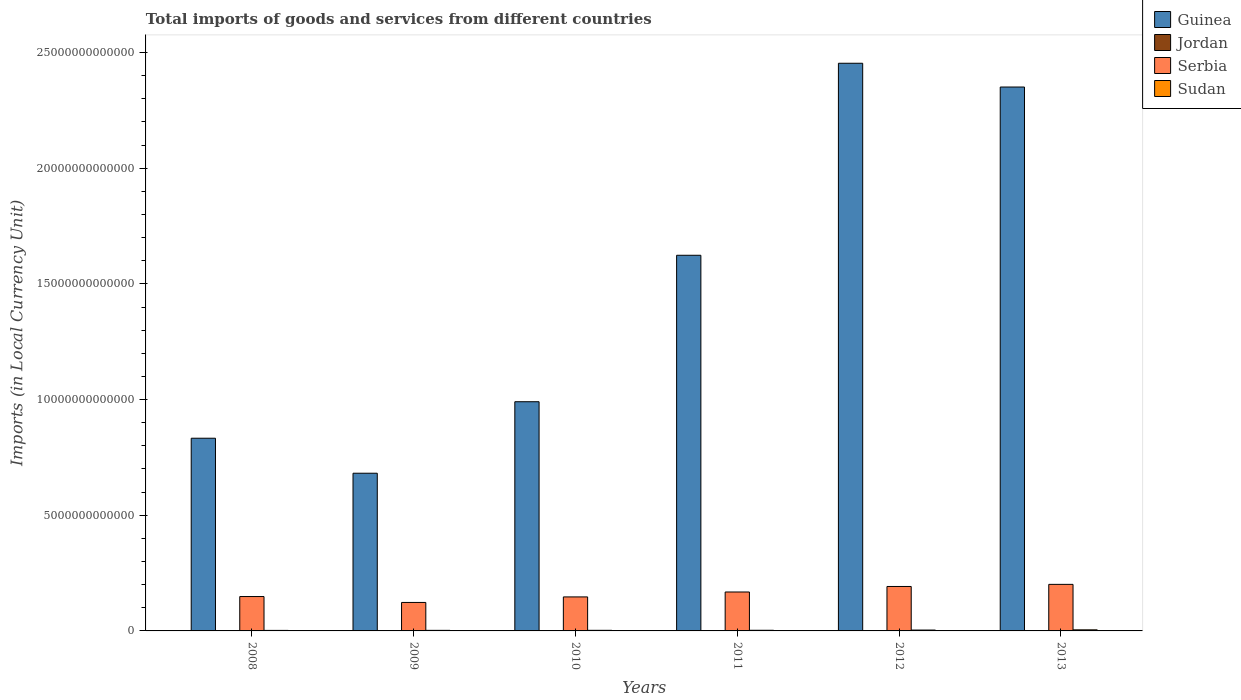How many groups of bars are there?
Your answer should be compact. 6. How many bars are there on the 2nd tick from the left?
Keep it short and to the point. 4. How many bars are there on the 4th tick from the right?
Your answer should be compact. 4. What is the label of the 4th group of bars from the left?
Provide a short and direct response. 2011. In how many cases, is the number of bars for a given year not equal to the number of legend labels?
Offer a terse response. 0. What is the Amount of goods and services imports in Guinea in 2013?
Provide a succinct answer. 2.35e+13. Across all years, what is the maximum Amount of goods and services imports in Serbia?
Provide a short and direct response. 2.01e+12. Across all years, what is the minimum Amount of goods and services imports in Guinea?
Ensure brevity in your answer.  6.82e+12. In which year was the Amount of goods and services imports in Guinea minimum?
Provide a short and direct response. 2009. What is the total Amount of goods and services imports in Guinea in the graph?
Ensure brevity in your answer.  8.93e+13. What is the difference between the Amount of goods and services imports in Serbia in 2010 and that in 2012?
Offer a terse response. -4.51e+11. What is the difference between the Amount of goods and services imports in Jordan in 2008 and the Amount of goods and services imports in Sudan in 2009?
Your answer should be compact. -1.08e+1. What is the average Amount of goods and services imports in Sudan per year?
Make the answer very short. 3.09e+1. In the year 2013, what is the difference between the Amount of goods and services imports in Guinea and Amount of goods and services imports in Serbia?
Provide a succinct answer. 2.15e+13. In how many years, is the Amount of goods and services imports in Guinea greater than 7000000000000 LCU?
Make the answer very short. 5. What is the ratio of the Amount of goods and services imports in Serbia in 2012 to that in 2013?
Make the answer very short. 0.95. Is the Amount of goods and services imports in Guinea in 2008 less than that in 2012?
Provide a succinct answer. Yes. What is the difference between the highest and the second highest Amount of goods and services imports in Sudan?
Your response must be concise. 9.45e+09. What is the difference between the highest and the lowest Amount of goods and services imports in Sudan?
Provide a succinct answer. 2.49e+1. Is the sum of the Amount of goods and services imports in Sudan in 2011 and 2012 greater than the maximum Amount of goods and services imports in Jordan across all years?
Give a very brief answer. Yes. What does the 3rd bar from the left in 2012 represents?
Offer a terse response. Serbia. What does the 4th bar from the right in 2008 represents?
Ensure brevity in your answer.  Guinea. Are all the bars in the graph horizontal?
Give a very brief answer. No. What is the difference between two consecutive major ticks on the Y-axis?
Your answer should be very brief. 5.00e+12. Does the graph contain grids?
Offer a very short reply. No. How are the legend labels stacked?
Make the answer very short. Vertical. What is the title of the graph?
Make the answer very short. Total imports of goods and services from different countries. Does "Channel Islands" appear as one of the legend labels in the graph?
Your answer should be compact. No. What is the label or title of the Y-axis?
Provide a short and direct response. Imports (in Local Currency Unit). What is the Imports (in Local Currency Unit) of Guinea in 2008?
Offer a very short reply. 8.33e+12. What is the Imports (in Local Currency Unit) of Jordan in 2008?
Your answer should be very brief. 1.36e+1. What is the Imports (in Local Currency Unit) in Serbia in 2008?
Ensure brevity in your answer.  1.49e+12. What is the Imports (in Local Currency Unit) in Sudan in 2008?
Offer a very short reply. 2.23e+1. What is the Imports (in Local Currency Unit) of Guinea in 2009?
Keep it short and to the point. 6.82e+12. What is the Imports (in Local Currency Unit) in Jordan in 2009?
Give a very brief answer. 1.17e+1. What is the Imports (in Local Currency Unit) of Serbia in 2009?
Offer a terse response. 1.23e+12. What is the Imports (in Local Currency Unit) of Sudan in 2009?
Provide a short and direct response. 2.45e+1. What is the Imports (in Local Currency Unit) in Guinea in 2010?
Your answer should be very brief. 9.91e+12. What is the Imports (in Local Currency Unit) of Jordan in 2010?
Offer a terse response. 1.30e+1. What is the Imports (in Local Currency Unit) of Serbia in 2010?
Your answer should be very brief. 1.47e+12. What is the Imports (in Local Currency Unit) of Sudan in 2010?
Your response must be concise. 2.61e+1. What is the Imports (in Local Currency Unit) of Guinea in 2011?
Ensure brevity in your answer.  1.62e+13. What is the Imports (in Local Currency Unit) in Jordan in 2011?
Provide a short and direct response. 1.51e+1. What is the Imports (in Local Currency Unit) in Serbia in 2011?
Offer a very short reply. 1.68e+12. What is the Imports (in Local Currency Unit) in Sudan in 2011?
Your answer should be compact. 2.79e+1. What is the Imports (in Local Currency Unit) of Guinea in 2012?
Make the answer very short. 2.45e+13. What is the Imports (in Local Currency Unit) in Jordan in 2012?
Provide a succinct answer. 1.63e+1. What is the Imports (in Local Currency Unit) in Serbia in 2012?
Make the answer very short. 1.92e+12. What is the Imports (in Local Currency Unit) in Sudan in 2012?
Provide a short and direct response. 3.77e+1. What is the Imports (in Local Currency Unit) of Guinea in 2013?
Provide a succinct answer. 2.35e+13. What is the Imports (in Local Currency Unit) of Jordan in 2013?
Offer a very short reply. 1.72e+1. What is the Imports (in Local Currency Unit) in Serbia in 2013?
Your answer should be very brief. 2.01e+12. What is the Imports (in Local Currency Unit) of Sudan in 2013?
Your response must be concise. 4.72e+1. Across all years, what is the maximum Imports (in Local Currency Unit) of Guinea?
Your answer should be compact. 2.45e+13. Across all years, what is the maximum Imports (in Local Currency Unit) of Jordan?
Offer a terse response. 1.72e+1. Across all years, what is the maximum Imports (in Local Currency Unit) in Serbia?
Make the answer very short. 2.01e+12. Across all years, what is the maximum Imports (in Local Currency Unit) in Sudan?
Offer a very short reply. 4.72e+1. Across all years, what is the minimum Imports (in Local Currency Unit) of Guinea?
Keep it short and to the point. 6.82e+12. Across all years, what is the minimum Imports (in Local Currency Unit) of Jordan?
Provide a short and direct response. 1.17e+1. Across all years, what is the minimum Imports (in Local Currency Unit) in Serbia?
Your answer should be very brief. 1.23e+12. Across all years, what is the minimum Imports (in Local Currency Unit) of Sudan?
Offer a very short reply. 2.23e+1. What is the total Imports (in Local Currency Unit) in Guinea in the graph?
Make the answer very short. 8.93e+13. What is the total Imports (in Local Currency Unit) of Jordan in the graph?
Give a very brief answer. 8.69e+1. What is the total Imports (in Local Currency Unit) of Serbia in the graph?
Your response must be concise. 9.80e+12. What is the total Imports (in Local Currency Unit) of Sudan in the graph?
Your answer should be very brief. 1.86e+11. What is the difference between the Imports (in Local Currency Unit) in Guinea in 2008 and that in 2009?
Offer a very short reply. 1.51e+12. What is the difference between the Imports (in Local Currency Unit) of Jordan in 2008 and that in 2009?
Your response must be concise. 1.96e+09. What is the difference between the Imports (in Local Currency Unit) in Serbia in 2008 and that in 2009?
Your response must be concise. 2.55e+11. What is the difference between the Imports (in Local Currency Unit) in Sudan in 2008 and that in 2009?
Keep it short and to the point. -2.14e+09. What is the difference between the Imports (in Local Currency Unit) of Guinea in 2008 and that in 2010?
Ensure brevity in your answer.  -1.58e+12. What is the difference between the Imports (in Local Currency Unit) in Jordan in 2008 and that in 2010?
Offer a terse response. 6.95e+08. What is the difference between the Imports (in Local Currency Unit) of Serbia in 2008 and that in 2010?
Ensure brevity in your answer.  1.62e+1. What is the difference between the Imports (in Local Currency Unit) in Sudan in 2008 and that in 2010?
Make the answer very short. -3.75e+09. What is the difference between the Imports (in Local Currency Unit) of Guinea in 2008 and that in 2011?
Your response must be concise. -7.91e+12. What is the difference between the Imports (in Local Currency Unit) of Jordan in 2008 and that in 2011?
Make the answer very short. -1.48e+09. What is the difference between the Imports (in Local Currency Unit) in Serbia in 2008 and that in 2011?
Provide a succinct answer. -1.96e+11. What is the difference between the Imports (in Local Currency Unit) in Sudan in 2008 and that in 2011?
Ensure brevity in your answer.  -5.58e+09. What is the difference between the Imports (in Local Currency Unit) in Guinea in 2008 and that in 2012?
Make the answer very short. -1.62e+13. What is the difference between the Imports (in Local Currency Unit) of Jordan in 2008 and that in 2012?
Your answer should be very brief. -2.67e+09. What is the difference between the Imports (in Local Currency Unit) in Serbia in 2008 and that in 2012?
Ensure brevity in your answer.  -4.35e+11. What is the difference between the Imports (in Local Currency Unit) in Sudan in 2008 and that in 2012?
Your answer should be compact. -1.54e+1. What is the difference between the Imports (in Local Currency Unit) of Guinea in 2008 and that in 2013?
Keep it short and to the point. -1.52e+13. What is the difference between the Imports (in Local Currency Unit) in Jordan in 2008 and that in 2013?
Keep it short and to the point. -3.52e+09. What is the difference between the Imports (in Local Currency Unit) in Serbia in 2008 and that in 2013?
Ensure brevity in your answer.  -5.26e+11. What is the difference between the Imports (in Local Currency Unit) of Sudan in 2008 and that in 2013?
Provide a short and direct response. -2.49e+1. What is the difference between the Imports (in Local Currency Unit) in Guinea in 2009 and that in 2010?
Give a very brief answer. -3.09e+12. What is the difference between the Imports (in Local Currency Unit) in Jordan in 2009 and that in 2010?
Your answer should be compact. -1.27e+09. What is the difference between the Imports (in Local Currency Unit) in Serbia in 2009 and that in 2010?
Provide a short and direct response. -2.39e+11. What is the difference between the Imports (in Local Currency Unit) of Sudan in 2009 and that in 2010?
Your answer should be very brief. -1.62e+09. What is the difference between the Imports (in Local Currency Unit) in Guinea in 2009 and that in 2011?
Keep it short and to the point. -9.42e+12. What is the difference between the Imports (in Local Currency Unit) in Jordan in 2009 and that in 2011?
Your response must be concise. -3.44e+09. What is the difference between the Imports (in Local Currency Unit) of Serbia in 2009 and that in 2011?
Provide a short and direct response. -4.51e+11. What is the difference between the Imports (in Local Currency Unit) of Sudan in 2009 and that in 2011?
Give a very brief answer. -3.44e+09. What is the difference between the Imports (in Local Currency Unit) of Guinea in 2009 and that in 2012?
Keep it short and to the point. -1.77e+13. What is the difference between the Imports (in Local Currency Unit) of Jordan in 2009 and that in 2012?
Provide a short and direct response. -4.63e+09. What is the difference between the Imports (in Local Currency Unit) in Serbia in 2009 and that in 2012?
Provide a succinct answer. -6.90e+11. What is the difference between the Imports (in Local Currency Unit) in Sudan in 2009 and that in 2012?
Ensure brevity in your answer.  -1.33e+1. What is the difference between the Imports (in Local Currency Unit) in Guinea in 2009 and that in 2013?
Your response must be concise. -1.67e+13. What is the difference between the Imports (in Local Currency Unit) in Jordan in 2009 and that in 2013?
Your response must be concise. -5.48e+09. What is the difference between the Imports (in Local Currency Unit) in Serbia in 2009 and that in 2013?
Provide a short and direct response. -7.81e+11. What is the difference between the Imports (in Local Currency Unit) of Sudan in 2009 and that in 2013?
Give a very brief answer. -2.27e+1. What is the difference between the Imports (in Local Currency Unit) of Guinea in 2010 and that in 2011?
Your answer should be compact. -6.33e+12. What is the difference between the Imports (in Local Currency Unit) of Jordan in 2010 and that in 2011?
Give a very brief answer. -2.17e+09. What is the difference between the Imports (in Local Currency Unit) of Serbia in 2010 and that in 2011?
Provide a succinct answer. -2.13e+11. What is the difference between the Imports (in Local Currency Unit) of Sudan in 2010 and that in 2011?
Offer a very short reply. -1.83e+09. What is the difference between the Imports (in Local Currency Unit) in Guinea in 2010 and that in 2012?
Offer a very short reply. -1.46e+13. What is the difference between the Imports (in Local Currency Unit) in Jordan in 2010 and that in 2012?
Provide a succinct answer. -3.36e+09. What is the difference between the Imports (in Local Currency Unit) of Serbia in 2010 and that in 2012?
Give a very brief answer. -4.51e+11. What is the difference between the Imports (in Local Currency Unit) in Sudan in 2010 and that in 2012?
Your response must be concise. -1.17e+1. What is the difference between the Imports (in Local Currency Unit) in Guinea in 2010 and that in 2013?
Make the answer very short. -1.36e+13. What is the difference between the Imports (in Local Currency Unit) of Jordan in 2010 and that in 2013?
Offer a very short reply. -4.21e+09. What is the difference between the Imports (in Local Currency Unit) of Serbia in 2010 and that in 2013?
Your answer should be very brief. -5.42e+11. What is the difference between the Imports (in Local Currency Unit) of Sudan in 2010 and that in 2013?
Offer a terse response. -2.11e+1. What is the difference between the Imports (in Local Currency Unit) in Guinea in 2011 and that in 2012?
Ensure brevity in your answer.  -8.30e+12. What is the difference between the Imports (in Local Currency Unit) in Jordan in 2011 and that in 2012?
Your response must be concise. -1.19e+09. What is the difference between the Imports (in Local Currency Unit) in Serbia in 2011 and that in 2012?
Ensure brevity in your answer.  -2.39e+11. What is the difference between the Imports (in Local Currency Unit) of Sudan in 2011 and that in 2012?
Make the answer very short. -9.83e+09. What is the difference between the Imports (in Local Currency Unit) in Guinea in 2011 and that in 2013?
Offer a terse response. -7.27e+12. What is the difference between the Imports (in Local Currency Unit) in Jordan in 2011 and that in 2013?
Offer a very short reply. -2.04e+09. What is the difference between the Imports (in Local Currency Unit) in Serbia in 2011 and that in 2013?
Provide a short and direct response. -3.30e+11. What is the difference between the Imports (in Local Currency Unit) of Sudan in 2011 and that in 2013?
Ensure brevity in your answer.  -1.93e+1. What is the difference between the Imports (in Local Currency Unit) of Guinea in 2012 and that in 2013?
Offer a terse response. 1.03e+12. What is the difference between the Imports (in Local Currency Unit) in Jordan in 2012 and that in 2013?
Make the answer very short. -8.50e+08. What is the difference between the Imports (in Local Currency Unit) of Serbia in 2012 and that in 2013?
Make the answer very short. -9.12e+1. What is the difference between the Imports (in Local Currency Unit) in Sudan in 2012 and that in 2013?
Your answer should be very brief. -9.45e+09. What is the difference between the Imports (in Local Currency Unit) in Guinea in 2008 and the Imports (in Local Currency Unit) in Jordan in 2009?
Your answer should be very brief. 8.32e+12. What is the difference between the Imports (in Local Currency Unit) in Guinea in 2008 and the Imports (in Local Currency Unit) in Serbia in 2009?
Keep it short and to the point. 7.10e+12. What is the difference between the Imports (in Local Currency Unit) of Guinea in 2008 and the Imports (in Local Currency Unit) of Sudan in 2009?
Offer a terse response. 8.30e+12. What is the difference between the Imports (in Local Currency Unit) in Jordan in 2008 and the Imports (in Local Currency Unit) in Serbia in 2009?
Your response must be concise. -1.22e+12. What is the difference between the Imports (in Local Currency Unit) of Jordan in 2008 and the Imports (in Local Currency Unit) of Sudan in 2009?
Make the answer very short. -1.08e+1. What is the difference between the Imports (in Local Currency Unit) of Serbia in 2008 and the Imports (in Local Currency Unit) of Sudan in 2009?
Offer a terse response. 1.46e+12. What is the difference between the Imports (in Local Currency Unit) of Guinea in 2008 and the Imports (in Local Currency Unit) of Jordan in 2010?
Your answer should be very brief. 8.32e+12. What is the difference between the Imports (in Local Currency Unit) in Guinea in 2008 and the Imports (in Local Currency Unit) in Serbia in 2010?
Your response must be concise. 6.86e+12. What is the difference between the Imports (in Local Currency Unit) in Guinea in 2008 and the Imports (in Local Currency Unit) in Sudan in 2010?
Your answer should be compact. 8.30e+12. What is the difference between the Imports (in Local Currency Unit) in Jordan in 2008 and the Imports (in Local Currency Unit) in Serbia in 2010?
Offer a terse response. -1.46e+12. What is the difference between the Imports (in Local Currency Unit) of Jordan in 2008 and the Imports (in Local Currency Unit) of Sudan in 2010?
Offer a very short reply. -1.24e+1. What is the difference between the Imports (in Local Currency Unit) of Serbia in 2008 and the Imports (in Local Currency Unit) of Sudan in 2010?
Keep it short and to the point. 1.46e+12. What is the difference between the Imports (in Local Currency Unit) of Guinea in 2008 and the Imports (in Local Currency Unit) of Jordan in 2011?
Offer a very short reply. 8.31e+12. What is the difference between the Imports (in Local Currency Unit) in Guinea in 2008 and the Imports (in Local Currency Unit) in Serbia in 2011?
Your response must be concise. 6.65e+12. What is the difference between the Imports (in Local Currency Unit) in Guinea in 2008 and the Imports (in Local Currency Unit) in Sudan in 2011?
Give a very brief answer. 8.30e+12. What is the difference between the Imports (in Local Currency Unit) in Jordan in 2008 and the Imports (in Local Currency Unit) in Serbia in 2011?
Ensure brevity in your answer.  -1.67e+12. What is the difference between the Imports (in Local Currency Unit) of Jordan in 2008 and the Imports (in Local Currency Unit) of Sudan in 2011?
Your answer should be compact. -1.43e+1. What is the difference between the Imports (in Local Currency Unit) in Serbia in 2008 and the Imports (in Local Currency Unit) in Sudan in 2011?
Ensure brevity in your answer.  1.46e+12. What is the difference between the Imports (in Local Currency Unit) in Guinea in 2008 and the Imports (in Local Currency Unit) in Jordan in 2012?
Your answer should be compact. 8.31e+12. What is the difference between the Imports (in Local Currency Unit) of Guinea in 2008 and the Imports (in Local Currency Unit) of Serbia in 2012?
Ensure brevity in your answer.  6.41e+12. What is the difference between the Imports (in Local Currency Unit) of Guinea in 2008 and the Imports (in Local Currency Unit) of Sudan in 2012?
Make the answer very short. 8.29e+12. What is the difference between the Imports (in Local Currency Unit) in Jordan in 2008 and the Imports (in Local Currency Unit) in Serbia in 2012?
Your answer should be compact. -1.91e+12. What is the difference between the Imports (in Local Currency Unit) in Jordan in 2008 and the Imports (in Local Currency Unit) in Sudan in 2012?
Provide a succinct answer. -2.41e+1. What is the difference between the Imports (in Local Currency Unit) in Serbia in 2008 and the Imports (in Local Currency Unit) in Sudan in 2012?
Your answer should be compact. 1.45e+12. What is the difference between the Imports (in Local Currency Unit) of Guinea in 2008 and the Imports (in Local Currency Unit) of Jordan in 2013?
Offer a terse response. 8.31e+12. What is the difference between the Imports (in Local Currency Unit) of Guinea in 2008 and the Imports (in Local Currency Unit) of Serbia in 2013?
Provide a succinct answer. 6.32e+12. What is the difference between the Imports (in Local Currency Unit) of Guinea in 2008 and the Imports (in Local Currency Unit) of Sudan in 2013?
Provide a short and direct response. 8.28e+12. What is the difference between the Imports (in Local Currency Unit) of Jordan in 2008 and the Imports (in Local Currency Unit) of Serbia in 2013?
Make the answer very short. -2.00e+12. What is the difference between the Imports (in Local Currency Unit) of Jordan in 2008 and the Imports (in Local Currency Unit) of Sudan in 2013?
Provide a succinct answer. -3.35e+1. What is the difference between the Imports (in Local Currency Unit) in Serbia in 2008 and the Imports (in Local Currency Unit) in Sudan in 2013?
Make the answer very short. 1.44e+12. What is the difference between the Imports (in Local Currency Unit) in Guinea in 2009 and the Imports (in Local Currency Unit) in Jordan in 2010?
Make the answer very short. 6.80e+12. What is the difference between the Imports (in Local Currency Unit) of Guinea in 2009 and the Imports (in Local Currency Unit) of Serbia in 2010?
Offer a very short reply. 5.35e+12. What is the difference between the Imports (in Local Currency Unit) of Guinea in 2009 and the Imports (in Local Currency Unit) of Sudan in 2010?
Offer a terse response. 6.79e+12. What is the difference between the Imports (in Local Currency Unit) in Jordan in 2009 and the Imports (in Local Currency Unit) in Serbia in 2010?
Keep it short and to the point. -1.46e+12. What is the difference between the Imports (in Local Currency Unit) in Jordan in 2009 and the Imports (in Local Currency Unit) in Sudan in 2010?
Provide a succinct answer. -1.44e+1. What is the difference between the Imports (in Local Currency Unit) in Serbia in 2009 and the Imports (in Local Currency Unit) in Sudan in 2010?
Your response must be concise. 1.20e+12. What is the difference between the Imports (in Local Currency Unit) of Guinea in 2009 and the Imports (in Local Currency Unit) of Jordan in 2011?
Provide a short and direct response. 6.80e+12. What is the difference between the Imports (in Local Currency Unit) of Guinea in 2009 and the Imports (in Local Currency Unit) of Serbia in 2011?
Give a very brief answer. 5.13e+12. What is the difference between the Imports (in Local Currency Unit) in Guinea in 2009 and the Imports (in Local Currency Unit) in Sudan in 2011?
Your response must be concise. 6.79e+12. What is the difference between the Imports (in Local Currency Unit) in Jordan in 2009 and the Imports (in Local Currency Unit) in Serbia in 2011?
Your answer should be compact. -1.67e+12. What is the difference between the Imports (in Local Currency Unit) in Jordan in 2009 and the Imports (in Local Currency Unit) in Sudan in 2011?
Offer a terse response. -1.62e+1. What is the difference between the Imports (in Local Currency Unit) in Serbia in 2009 and the Imports (in Local Currency Unit) in Sudan in 2011?
Provide a succinct answer. 1.20e+12. What is the difference between the Imports (in Local Currency Unit) of Guinea in 2009 and the Imports (in Local Currency Unit) of Jordan in 2012?
Your answer should be compact. 6.80e+12. What is the difference between the Imports (in Local Currency Unit) of Guinea in 2009 and the Imports (in Local Currency Unit) of Serbia in 2012?
Make the answer very short. 4.89e+12. What is the difference between the Imports (in Local Currency Unit) of Guinea in 2009 and the Imports (in Local Currency Unit) of Sudan in 2012?
Keep it short and to the point. 6.78e+12. What is the difference between the Imports (in Local Currency Unit) in Jordan in 2009 and the Imports (in Local Currency Unit) in Serbia in 2012?
Provide a short and direct response. -1.91e+12. What is the difference between the Imports (in Local Currency Unit) in Jordan in 2009 and the Imports (in Local Currency Unit) in Sudan in 2012?
Provide a short and direct response. -2.61e+1. What is the difference between the Imports (in Local Currency Unit) in Serbia in 2009 and the Imports (in Local Currency Unit) in Sudan in 2012?
Keep it short and to the point. 1.19e+12. What is the difference between the Imports (in Local Currency Unit) of Guinea in 2009 and the Imports (in Local Currency Unit) of Jordan in 2013?
Keep it short and to the point. 6.80e+12. What is the difference between the Imports (in Local Currency Unit) of Guinea in 2009 and the Imports (in Local Currency Unit) of Serbia in 2013?
Your response must be concise. 4.80e+12. What is the difference between the Imports (in Local Currency Unit) in Guinea in 2009 and the Imports (in Local Currency Unit) in Sudan in 2013?
Your response must be concise. 6.77e+12. What is the difference between the Imports (in Local Currency Unit) in Jordan in 2009 and the Imports (in Local Currency Unit) in Serbia in 2013?
Give a very brief answer. -2.00e+12. What is the difference between the Imports (in Local Currency Unit) of Jordan in 2009 and the Imports (in Local Currency Unit) of Sudan in 2013?
Offer a terse response. -3.55e+1. What is the difference between the Imports (in Local Currency Unit) in Serbia in 2009 and the Imports (in Local Currency Unit) in Sudan in 2013?
Make the answer very short. 1.18e+12. What is the difference between the Imports (in Local Currency Unit) in Guinea in 2010 and the Imports (in Local Currency Unit) in Jordan in 2011?
Ensure brevity in your answer.  9.89e+12. What is the difference between the Imports (in Local Currency Unit) in Guinea in 2010 and the Imports (in Local Currency Unit) in Serbia in 2011?
Keep it short and to the point. 8.22e+12. What is the difference between the Imports (in Local Currency Unit) in Guinea in 2010 and the Imports (in Local Currency Unit) in Sudan in 2011?
Your answer should be compact. 9.88e+12. What is the difference between the Imports (in Local Currency Unit) of Jordan in 2010 and the Imports (in Local Currency Unit) of Serbia in 2011?
Your response must be concise. -1.67e+12. What is the difference between the Imports (in Local Currency Unit) of Jordan in 2010 and the Imports (in Local Currency Unit) of Sudan in 2011?
Make the answer very short. -1.50e+1. What is the difference between the Imports (in Local Currency Unit) of Serbia in 2010 and the Imports (in Local Currency Unit) of Sudan in 2011?
Keep it short and to the point. 1.44e+12. What is the difference between the Imports (in Local Currency Unit) of Guinea in 2010 and the Imports (in Local Currency Unit) of Jordan in 2012?
Your answer should be compact. 9.89e+12. What is the difference between the Imports (in Local Currency Unit) in Guinea in 2010 and the Imports (in Local Currency Unit) in Serbia in 2012?
Offer a very short reply. 7.98e+12. What is the difference between the Imports (in Local Currency Unit) of Guinea in 2010 and the Imports (in Local Currency Unit) of Sudan in 2012?
Offer a terse response. 9.87e+12. What is the difference between the Imports (in Local Currency Unit) in Jordan in 2010 and the Imports (in Local Currency Unit) in Serbia in 2012?
Your response must be concise. -1.91e+12. What is the difference between the Imports (in Local Currency Unit) in Jordan in 2010 and the Imports (in Local Currency Unit) in Sudan in 2012?
Keep it short and to the point. -2.48e+1. What is the difference between the Imports (in Local Currency Unit) of Serbia in 2010 and the Imports (in Local Currency Unit) of Sudan in 2012?
Offer a terse response. 1.43e+12. What is the difference between the Imports (in Local Currency Unit) of Guinea in 2010 and the Imports (in Local Currency Unit) of Jordan in 2013?
Provide a short and direct response. 9.89e+12. What is the difference between the Imports (in Local Currency Unit) of Guinea in 2010 and the Imports (in Local Currency Unit) of Serbia in 2013?
Give a very brief answer. 7.89e+12. What is the difference between the Imports (in Local Currency Unit) in Guinea in 2010 and the Imports (in Local Currency Unit) in Sudan in 2013?
Your answer should be very brief. 9.86e+12. What is the difference between the Imports (in Local Currency Unit) in Jordan in 2010 and the Imports (in Local Currency Unit) in Serbia in 2013?
Make the answer very short. -2.00e+12. What is the difference between the Imports (in Local Currency Unit) in Jordan in 2010 and the Imports (in Local Currency Unit) in Sudan in 2013?
Your response must be concise. -3.42e+1. What is the difference between the Imports (in Local Currency Unit) in Serbia in 2010 and the Imports (in Local Currency Unit) in Sudan in 2013?
Provide a succinct answer. 1.42e+12. What is the difference between the Imports (in Local Currency Unit) of Guinea in 2011 and the Imports (in Local Currency Unit) of Jordan in 2012?
Your answer should be very brief. 1.62e+13. What is the difference between the Imports (in Local Currency Unit) in Guinea in 2011 and the Imports (in Local Currency Unit) in Serbia in 2012?
Your answer should be compact. 1.43e+13. What is the difference between the Imports (in Local Currency Unit) in Guinea in 2011 and the Imports (in Local Currency Unit) in Sudan in 2012?
Offer a terse response. 1.62e+13. What is the difference between the Imports (in Local Currency Unit) of Jordan in 2011 and the Imports (in Local Currency Unit) of Serbia in 2012?
Your answer should be compact. -1.91e+12. What is the difference between the Imports (in Local Currency Unit) of Jordan in 2011 and the Imports (in Local Currency Unit) of Sudan in 2012?
Give a very brief answer. -2.26e+1. What is the difference between the Imports (in Local Currency Unit) in Serbia in 2011 and the Imports (in Local Currency Unit) in Sudan in 2012?
Your answer should be very brief. 1.64e+12. What is the difference between the Imports (in Local Currency Unit) of Guinea in 2011 and the Imports (in Local Currency Unit) of Jordan in 2013?
Give a very brief answer. 1.62e+13. What is the difference between the Imports (in Local Currency Unit) of Guinea in 2011 and the Imports (in Local Currency Unit) of Serbia in 2013?
Offer a terse response. 1.42e+13. What is the difference between the Imports (in Local Currency Unit) in Guinea in 2011 and the Imports (in Local Currency Unit) in Sudan in 2013?
Your response must be concise. 1.62e+13. What is the difference between the Imports (in Local Currency Unit) in Jordan in 2011 and the Imports (in Local Currency Unit) in Serbia in 2013?
Keep it short and to the point. -2.00e+12. What is the difference between the Imports (in Local Currency Unit) in Jordan in 2011 and the Imports (in Local Currency Unit) in Sudan in 2013?
Keep it short and to the point. -3.21e+1. What is the difference between the Imports (in Local Currency Unit) in Serbia in 2011 and the Imports (in Local Currency Unit) in Sudan in 2013?
Provide a succinct answer. 1.64e+12. What is the difference between the Imports (in Local Currency Unit) in Guinea in 2012 and the Imports (in Local Currency Unit) in Jordan in 2013?
Offer a terse response. 2.45e+13. What is the difference between the Imports (in Local Currency Unit) of Guinea in 2012 and the Imports (in Local Currency Unit) of Serbia in 2013?
Offer a very short reply. 2.25e+13. What is the difference between the Imports (in Local Currency Unit) of Guinea in 2012 and the Imports (in Local Currency Unit) of Sudan in 2013?
Make the answer very short. 2.45e+13. What is the difference between the Imports (in Local Currency Unit) of Jordan in 2012 and the Imports (in Local Currency Unit) of Serbia in 2013?
Provide a short and direct response. -2.00e+12. What is the difference between the Imports (in Local Currency Unit) in Jordan in 2012 and the Imports (in Local Currency Unit) in Sudan in 2013?
Your answer should be very brief. -3.09e+1. What is the difference between the Imports (in Local Currency Unit) of Serbia in 2012 and the Imports (in Local Currency Unit) of Sudan in 2013?
Your response must be concise. 1.87e+12. What is the average Imports (in Local Currency Unit) of Guinea per year?
Provide a short and direct response. 1.49e+13. What is the average Imports (in Local Currency Unit) in Jordan per year?
Your answer should be very brief. 1.45e+1. What is the average Imports (in Local Currency Unit) of Serbia per year?
Your answer should be compact. 1.63e+12. What is the average Imports (in Local Currency Unit) in Sudan per year?
Make the answer very short. 3.09e+1. In the year 2008, what is the difference between the Imports (in Local Currency Unit) in Guinea and Imports (in Local Currency Unit) in Jordan?
Your response must be concise. 8.31e+12. In the year 2008, what is the difference between the Imports (in Local Currency Unit) of Guinea and Imports (in Local Currency Unit) of Serbia?
Provide a short and direct response. 6.84e+12. In the year 2008, what is the difference between the Imports (in Local Currency Unit) of Guinea and Imports (in Local Currency Unit) of Sudan?
Your response must be concise. 8.31e+12. In the year 2008, what is the difference between the Imports (in Local Currency Unit) of Jordan and Imports (in Local Currency Unit) of Serbia?
Keep it short and to the point. -1.47e+12. In the year 2008, what is the difference between the Imports (in Local Currency Unit) in Jordan and Imports (in Local Currency Unit) in Sudan?
Provide a short and direct response. -8.68e+09. In the year 2008, what is the difference between the Imports (in Local Currency Unit) in Serbia and Imports (in Local Currency Unit) in Sudan?
Offer a very short reply. 1.46e+12. In the year 2009, what is the difference between the Imports (in Local Currency Unit) of Guinea and Imports (in Local Currency Unit) of Jordan?
Offer a terse response. 6.80e+12. In the year 2009, what is the difference between the Imports (in Local Currency Unit) of Guinea and Imports (in Local Currency Unit) of Serbia?
Make the answer very short. 5.58e+12. In the year 2009, what is the difference between the Imports (in Local Currency Unit) of Guinea and Imports (in Local Currency Unit) of Sudan?
Keep it short and to the point. 6.79e+12. In the year 2009, what is the difference between the Imports (in Local Currency Unit) of Jordan and Imports (in Local Currency Unit) of Serbia?
Offer a very short reply. -1.22e+12. In the year 2009, what is the difference between the Imports (in Local Currency Unit) of Jordan and Imports (in Local Currency Unit) of Sudan?
Provide a succinct answer. -1.28e+1. In the year 2009, what is the difference between the Imports (in Local Currency Unit) in Serbia and Imports (in Local Currency Unit) in Sudan?
Provide a short and direct response. 1.21e+12. In the year 2010, what is the difference between the Imports (in Local Currency Unit) of Guinea and Imports (in Local Currency Unit) of Jordan?
Offer a very short reply. 9.89e+12. In the year 2010, what is the difference between the Imports (in Local Currency Unit) in Guinea and Imports (in Local Currency Unit) in Serbia?
Give a very brief answer. 8.44e+12. In the year 2010, what is the difference between the Imports (in Local Currency Unit) of Guinea and Imports (in Local Currency Unit) of Sudan?
Keep it short and to the point. 9.88e+12. In the year 2010, what is the difference between the Imports (in Local Currency Unit) of Jordan and Imports (in Local Currency Unit) of Serbia?
Offer a terse response. -1.46e+12. In the year 2010, what is the difference between the Imports (in Local Currency Unit) in Jordan and Imports (in Local Currency Unit) in Sudan?
Offer a very short reply. -1.31e+1. In the year 2010, what is the difference between the Imports (in Local Currency Unit) of Serbia and Imports (in Local Currency Unit) of Sudan?
Make the answer very short. 1.44e+12. In the year 2011, what is the difference between the Imports (in Local Currency Unit) of Guinea and Imports (in Local Currency Unit) of Jordan?
Provide a succinct answer. 1.62e+13. In the year 2011, what is the difference between the Imports (in Local Currency Unit) in Guinea and Imports (in Local Currency Unit) in Serbia?
Offer a very short reply. 1.46e+13. In the year 2011, what is the difference between the Imports (in Local Currency Unit) of Guinea and Imports (in Local Currency Unit) of Sudan?
Your answer should be compact. 1.62e+13. In the year 2011, what is the difference between the Imports (in Local Currency Unit) of Jordan and Imports (in Local Currency Unit) of Serbia?
Ensure brevity in your answer.  -1.67e+12. In the year 2011, what is the difference between the Imports (in Local Currency Unit) in Jordan and Imports (in Local Currency Unit) in Sudan?
Provide a succinct answer. -1.28e+1. In the year 2011, what is the difference between the Imports (in Local Currency Unit) of Serbia and Imports (in Local Currency Unit) of Sudan?
Offer a very short reply. 1.65e+12. In the year 2012, what is the difference between the Imports (in Local Currency Unit) in Guinea and Imports (in Local Currency Unit) in Jordan?
Keep it short and to the point. 2.45e+13. In the year 2012, what is the difference between the Imports (in Local Currency Unit) in Guinea and Imports (in Local Currency Unit) in Serbia?
Ensure brevity in your answer.  2.26e+13. In the year 2012, what is the difference between the Imports (in Local Currency Unit) in Guinea and Imports (in Local Currency Unit) in Sudan?
Keep it short and to the point. 2.45e+13. In the year 2012, what is the difference between the Imports (in Local Currency Unit) in Jordan and Imports (in Local Currency Unit) in Serbia?
Your answer should be compact. -1.90e+12. In the year 2012, what is the difference between the Imports (in Local Currency Unit) in Jordan and Imports (in Local Currency Unit) in Sudan?
Offer a very short reply. -2.14e+1. In the year 2012, what is the difference between the Imports (in Local Currency Unit) in Serbia and Imports (in Local Currency Unit) in Sudan?
Make the answer very short. 1.88e+12. In the year 2013, what is the difference between the Imports (in Local Currency Unit) of Guinea and Imports (in Local Currency Unit) of Jordan?
Your response must be concise. 2.35e+13. In the year 2013, what is the difference between the Imports (in Local Currency Unit) in Guinea and Imports (in Local Currency Unit) in Serbia?
Your answer should be compact. 2.15e+13. In the year 2013, what is the difference between the Imports (in Local Currency Unit) in Guinea and Imports (in Local Currency Unit) in Sudan?
Offer a very short reply. 2.35e+13. In the year 2013, what is the difference between the Imports (in Local Currency Unit) in Jordan and Imports (in Local Currency Unit) in Serbia?
Your answer should be very brief. -2.00e+12. In the year 2013, what is the difference between the Imports (in Local Currency Unit) of Jordan and Imports (in Local Currency Unit) of Sudan?
Ensure brevity in your answer.  -3.00e+1. In the year 2013, what is the difference between the Imports (in Local Currency Unit) of Serbia and Imports (in Local Currency Unit) of Sudan?
Provide a succinct answer. 1.97e+12. What is the ratio of the Imports (in Local Currency Unit) of Guinea in 2008 to that in 2009?
Provide a succinct answer. 1.22. What is the ratio of the Imports (in Local Currency Unit) in Jordan in 2008 to that in 2009?
Provide a succinct answer. 1.17. What is the ratio of the Imports (in Local Currency Unit) of Serbia in 2008 to that in 2009?
Provide a short and direct response. 1.21. What is the ratio of the Imports (in Local Currency Unit) in Sudan in 2008 to that in 2009?
Offer a very short reply. 0.91. What is the ratio of the Imports (in Local Currency Unit) of Guinea in 2008 to that in 2010?
Offer a very short reply. 0.84. What is the ratio of the Imports (in Local Currency Unit) of Jordan in 2008 to that in 2010?
Your answer should be compact. 1.05. What is the ratio of the Imports (in Local Currency Unit) in Sudan in 2008 to that in 2010?
Offer a terse response. 0.86. What is the ratio of the Imports (in Local Currency Unit) in Guinea in 2008 to that in 2011?
Your answer should be compact. 0.51. What is the ratio of the Imports (in Local Currency Unit) in Jordan in 2008 to that in 2011?
Provide a short and direct response. 0.9. What is the ratio of the Imports (in Local Currency Unit) of Serbia in 2008 to that in 2011?
Your answer should be very brief. 0.88. What is the ratio of the Imports (in Local Currency Unit) in Guinea in 2008 to that in 2012?
Offer a terse response. 0.34. What is the ratio of the Imports (in Local Currency Unit) of Jordan in 2008 to that in 2012?
Give a very brief answer. 0.84. What is the ratio of the Imports (in Local Currency Unit) in Serbia in 2008 to that in 2012?
Give a very brief answer. 0.77. What is the ratio of the Imports (in Local Currency Unit) of Sudan in 2008 to that in 2012?
Your answer should be very brief. 0.59. What is the ratio of the Imports (in Local Currency Unit) of Guinea in 2008 to that in 2013?
Provide a succinct answer. 0.35. What is the ratio of the Imports (in Local Currency Unit) in Jordan in 2008 to that in 2013?
Offer a terse response. 0.8. What is the ratio of the Imports (in Local Currency Unit) in Serbia in 2008 to that in 2013?
Provide a short and direct response. 0.74. What is the ratio of the Imports (in Local Currency Unit) in Sudan in 2008 to that in 2013?
Offer a terse response. 0.47. What is the ratio of the Imports (in Local Currency Unit) of Guinea in 2009 to that in 2010?
Offer a terse response. 0.69. What is the ratio of the Imports (in Local Currency Unit) of Jordan in 2009 to that in 2010?
Ensure brevity in your answer.  0.9. What is the ratio of the Imports (in Local Currency Unit) in Serbia in 2009 to that in 2010?
Offer a very short reply. 0.84. What is the ratio of the Imports (in Local Currency Unit) in Sudan in 2009 to that in 2010?
Give a very brief answer. 0.94. What is the ratio of the Imports (in Local Currency Unit) of Guinea in 2009 to that in 2011?
Your response must be concise. 0.42. What is the ratio of the Imports (in Local Currency Unit) of Jordan in 2009 to that in 2011?
Your answer should be compact. 0.77. What is the ratio of the Imports (in Local Currency Unit) of Serbia in 2009 to that in 2011?
Provide a succinct answer. 0.73. What is the ratio of the Imports (in Local Currency Unit) of Sudan in 2009 to that in 2011?
Offer a very short reply. 0.88. What is the ratio of the Imports (in Local Currency Unit) in Guinea in 2009 to that in 2012?
Make the answer very short. 0.28. What is the ratio of the Imports (in Local Currency Unit) in Jordan in 2009 to that in 2012?
Your answer should be compact. 0.72. What is the ratio of the Imports (in Local Currency Unit) in Serbia in 2009 to that in 2012?
Offer a very short reply. 0.64. What is the ratio of the Imports (in Local Currency Unit) in Sudan in 2009 to that in 2012?
Offer a very short reply. 0.65. What is the ratio of the Imports (in Local Currency Unit) in Guinea in 2009 to that in 2013?
Make the answer very short. 0.29. What is the ratio of the Imports (in Local Currency Unit) in Jordan in 2009 to that in 2013?
Give a very brief answer. 0.68. What is the ratio of the Imports (in Local Currency Unit) of Serbia in 2009 to that in 2013?
Give a very brief answer. 0.61. What is the ratio of the Imports (in Local Currency Unit) in Sudan in 2009 to that in 2013?
Keep it short and to the point. 0.52. What is the ratio of the Imports (in Local Currency Unit) of Guinea in 2010 to that in 2011?
Your answer should be compact. 0.61. What is the ratio of the Imports (in Local Currency Unit) in Jordan in 2010 to that in 2011?
Offer a terse response. 0.86. What is the ratio of the Imports (in Local Currency Unit) of Serbia in 2010 to that in 2011?
Your answer should be very brief. 0.87. What is the ratio of the Imports (in Local Currency Unit) of Sudan in 2010 to that in 2011?
Provide a short and direct response. 0.93. What is the ratio of the Imports (in Local Currency Unit) of Guinea in 2010 to that in 2012?
Offer a very short reply. 0.4. What is the ratio of the Imports (in Local Currency Unit) in Jordan in 2010 to that in 2012?
Offer a terse response. 0.79. What is the ratio of the Imports (in Local Currency Unit) of Serbia in 2010 to that in 2012?
Offer a very short reply. 0.77. What is the ratio of the Imports (in Local Currency Unit) in Sudan in 2010 to that in 2012?
Provide a short and direct response. 0.69. What is the ratio of the Imports (in Local Currency Unit) in Guinea in 2010 to that in 2013?
Offer a very short reply. 0.42. What is the ratio of the Imports (in Local Currency Unit) in Jordan in 2010 to that in 2013?
Ensure brevity in your answer.  0.75. What is the ratio of the Imports (in Local Currency Unit) of Serbia in 2010 to that in 2013?
Make the answer very short. 0.73. What is the ratio of the Imports (in Local Currency Unit) in Sudan in 2010 to that in 2013?
Provide a succinct answer. 0.55. What is the ratio of the Imports (in Local Currency Unit) in Guinea in 2011 to that in 2012?
Make the answer very short. 0.66. What is the ratio of the Imports (in Local Currency Unit) in Jordan in 2011 to that in 2012?
Offer a very short reply. 0.93. What is the ratio of the Imports (in Local Currency Unit) of Serbia in 2011 to that in 2012?
Keep it short and to the point. 0.88. What is the ratio of the Imports (in Local Currency Unit) of Sudan in 2011 to that in 2012?
Ensure brevity in your answer.  0.74. What is the ratio of the Imports (in Local Currency Unit) of Guinea in 2011 to that in 2013?
Give a very brief answer. 0.69. What is the ratio of the Imports (in Local Currency Unit) of Jordan in 2011 to that in 2013?
Offer a terse response. 0.88. What is the ratio of the Imports (in Local Currency Unit) in Serbia in 2011 to that in 2013?
Provide a succinct answer. 0.84. What is the ratio of the Imports (in Local Currency Unit) of Sudan in 2011 to that in 2013?
Your answer should be compact. 0.59. What is the ratio of the Imports (in Local Currency Unit) of Guinea in 2012 to that in 2013?
Give a very brief answer. 1.04. What is the ratio of the Imports (in Local Currency Unit) of Jordan in 2012 to that in 2013?
Offer a terse response. 0.95. What is the ratio of the Imports (in Local Currency Unit) of Serbia in 2012 to that in 2013?
Your response must be concise. 0.95. What is the ratio of the Imports (in Local Currency Unit) of Sudan in 2012 to that in 2013?
Provide a short and direct response. 0.8. What is the difference between the highest and the second highest Imports (in Local Currency Unit) in Guinea?
Offer a terse response. 1.03e+12. What is the difference between the highest and the second highest Imports (in Local Currency Unit) in Jordan?
Your answer should be very brief. 8.50e+08. What is the difference between the highest and the second highest Imports (in Local Currency Unit) of Serbia?
Offer a very short reply. 9.12e+1. What is the difference between the highest and the second highest Imports (in Local Currency Unit) of Sudan?
Ensure brevity in your answer.  9.45e+09. What is the difference between the highest and the lowest Imports (in Local Currency Unit) in Guinea?
Your response must be concise. 1.77e+13. What is the difference between the highest and the lowest Imports (in Local Currency Unit) of Jordan?
Make the answer very short. 5.48e+09. What is the difference between the highest and the lowest Imports (in Local Currency Unit) in Serbia?
Offer a very short reply. 7.81e+11. What is the difference between the highest and the lowest Imports (in Local Currency Unit) in Sudan?
Make the answer very short. 2.49e+1. 